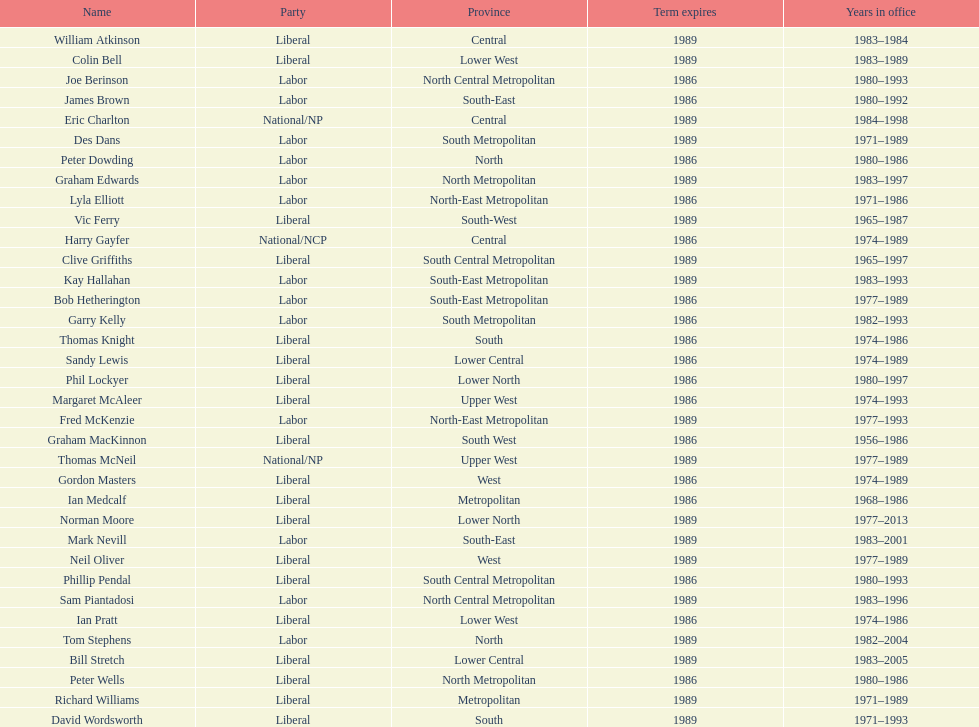Who experienced the briefest tenure in office? William Atkinson. 